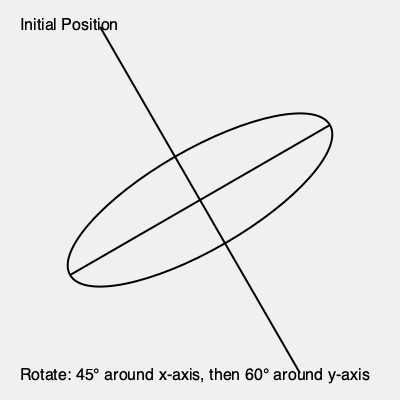As a tennis enthusiast, imagine you're designing a 3D model of your favorite racket for a virtual tennis game. The initial position of the racket is shown in the diagram, rotated 30° counterclockwise around the z-axis. You need to apply two consecutive rotations to match the game's required orientation: first, a 45° rotation around the x-axis, followed by a 60° rotation around the y-axis. What will be the final orientation of the racket's long axis (handle to tip) relative to the positive z-axis? Let's approach this step-by-step:

1) Initial position: The racket is rotated 30° counterclockwise around the z-axis. Its long axis is still in the x-z plane.

2) First rotation: 45° around the x-axis
   This tilts the racket's plane 45° around the x-axis, moving the long axis out of the x-z plane.

3) Second rotation: 60° around the y-axis
   This rotation moves the long axis further from its original position.

4) To find the final orientation, we need to use 3D rotation matrices. However, a simpler approach is to consider the angle between the long axis and the z-axis.

5) The angle between the long axis and the z-axis after these rotations can be calculated using the formula:

   $$\cos \theta = \cos A \cos B$$

   Where $\theta$ is the angle we're looking for, A is the angle of rotation around the x-axis (45°), and B is the angle of rotation around the y-axis (60°).

6) Plugging in the values:

   $$\cos \theta = \cos 45° \cos 60°$$
   $$\cos \theta = (\frac{\sqrt{2}}{2}) (\frac{1}{2}) = \frac{\sqrt{2}}{4}$$

7) Taking the inverse cosine (arccos) of both sides:

   $$\theta = \arccos(\frac{\sqrt{2}}{4}) \approx 74.5°$$

Thus, the final orientation of the racket's long axis will be approximately 74.5° from the positive z-axis.
Answer: 74.5° 